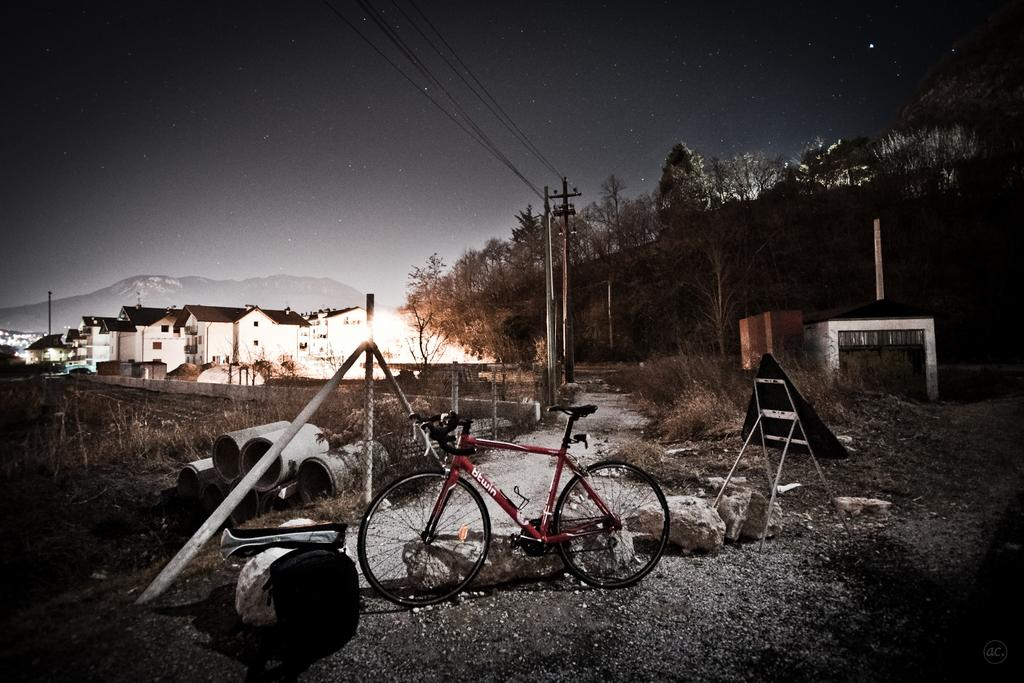What is the main object in the image? There is a bicycle in the image. What else can be seen in the image besides the bicycle? There is a ladder, trees, buildings on the left side, poles, and wires in the image. Can you describe the surroundings of the bicycle? The bicycle is surrounded by trees, poles, and wires. What type of structures are visible on the left side of the image? There are buildings on the left side of the image. How many steps does the bicycle take during its voyage in the image? The bicycle does not take any steps or go on a voyage in the image; it is stationary. What type of walk is depicted in the image? There is no walk depicted in the image; it features a bicycle, a ladder, trees, buildings, poles, and wires. 